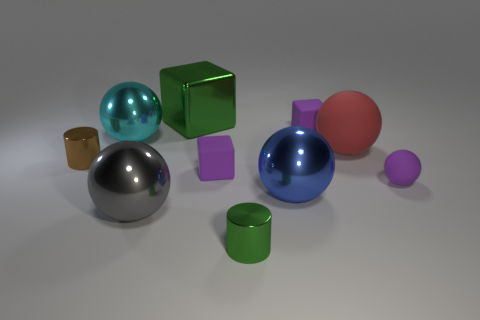Are there any green cylinders that are in front of the small shiny cylinder to the left of the gray metal sphere that is right of the small brown metallic cylinder?
Provide a succinct answer. Yes. What color is the large cube that is the same material as the gray object?
Provide a short and direct response. Green. What number of tiny balls have the same material as the gray object?
Provide a succinct answer. 0. Is the small green cylinder made of the same material as the large ball that is in front of the blue thing?
Provide a short and direct response. Yes. What number of objects are spheres that are to the right of the big gray thing or tiny green blocks?
Offer a very short reply. 3. There is a gray ball that is in front of the rubber cube that is right of the tiny purple block that is on the left side of the big blue shiny object; what is its size?
Your answer should be compact. Large. What material is the tiny object that is the same color as the large cube?
Offer a very short reply. Metal. How big is the purple thing left of the cylinder that is in front of the blue metal object?
Your response must be concise. Small. How many small objects are gray shiny objects or gray matte spheres?
Provide a succinct answer. 0. Are there fewer tiny matte blocks than large metal spheres?
Make the answer very short. Yes. 